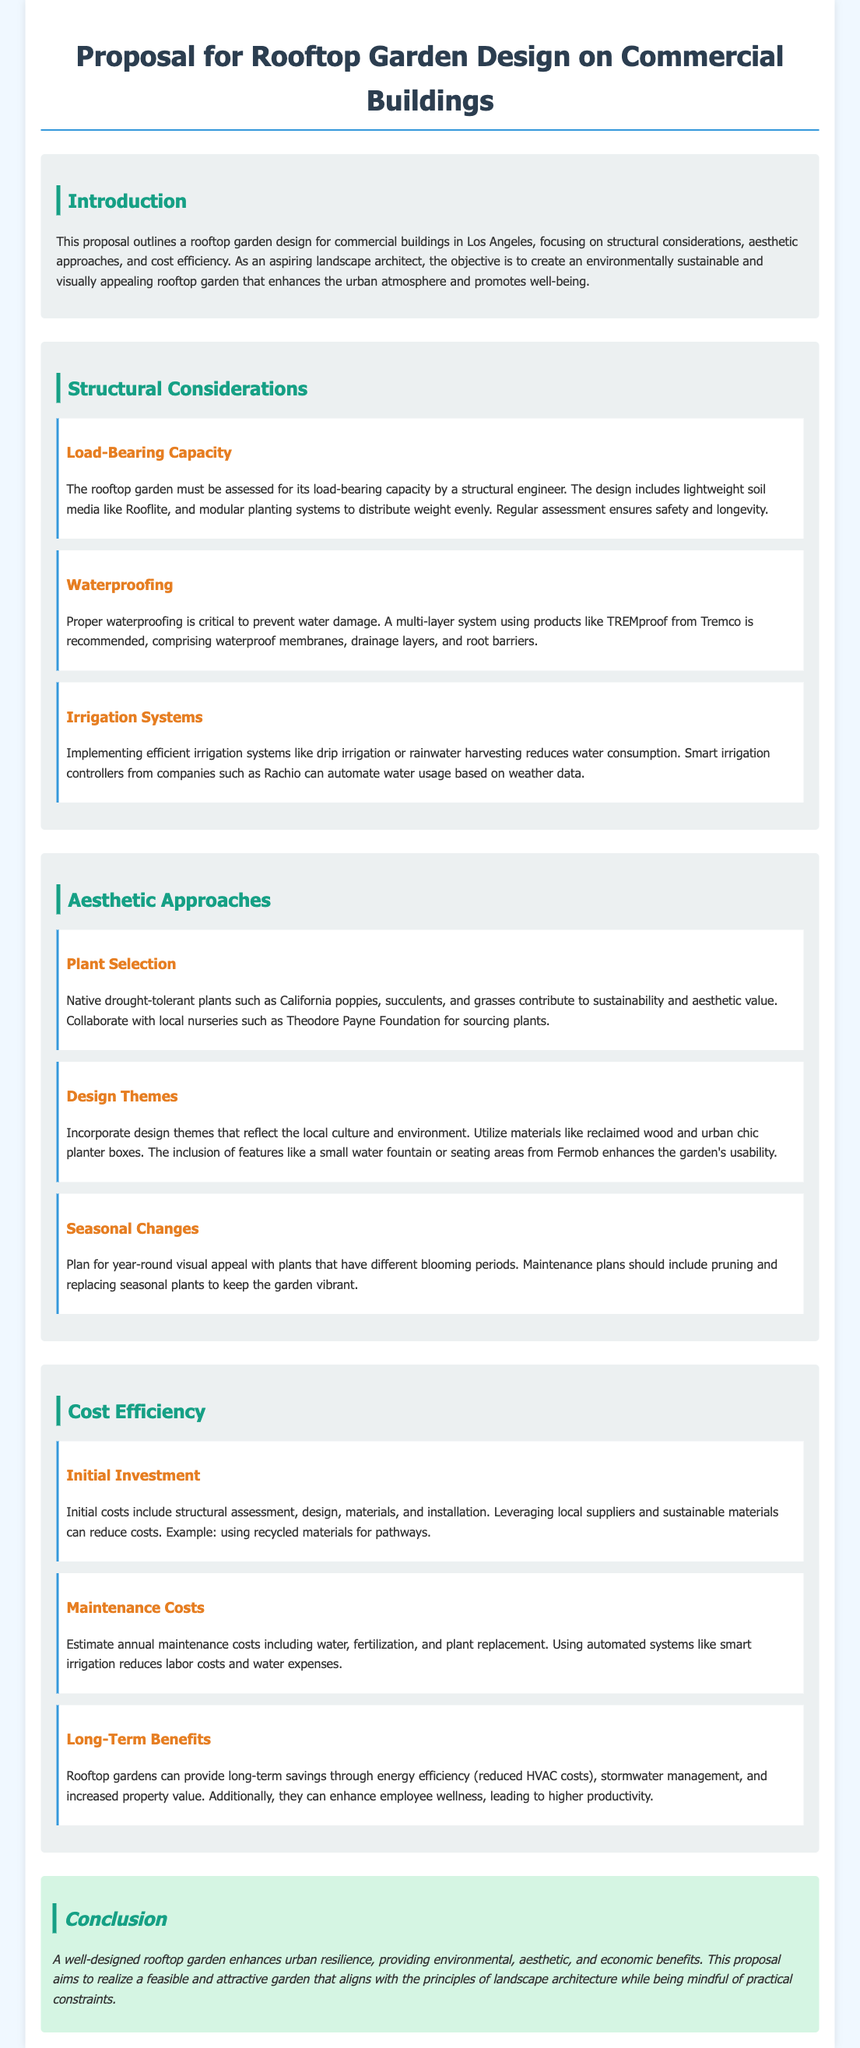what is the title of the proposal? The title is specifically mentioned at the beginning of the document as the focus of the proposal.
Answer: Proposal for Rooftop Garden Design on Commercial Buildings who should assess the load-bearing capacity of the rooftop garden? This information is stated in the structural considerations section, indicating a professional role responsible for the assessment.
Answer: Structural engineer what type of irrigation system is recommended for efficiency? The document suggests specific irrigation systems known for their efficiency in water usage within the irrigation systems subsection.
Answer: Drip irrigation what is the purpose of using lightweight soil media like Rooflite? The reason is specified in the load-bearing capacity subsection, highlighting its importance in weight distribution.
Answer: Distribute weight evenly which type of plants are recommended for the garden design? Native plants are specified in the aesthetic approaches section, reflecting the document's emphasis on sustainability.
Answer: Native drought-tolerant plants what is one long-term benefit of rooftop gardens mentioned? The document elaborates on multiple long-term savings associated with rooftop gardens, and one such benefit is highlighted distinctly.
Answer: Energy efficiency what is suggested to enhance the garden's usability? The aesthetic approaches section includes features designed to improve functionality, indicating which elements are important for usability.
Answer: Seating areas what should maintenance plans include for year-round appeal? The document outlines specific tasks needed for upkeep and seasonal visual interest, indicating what should be part of these plans.
Answer: Pruning and replacing seasonal plants how can initial costs be reduced according to the proposal? The proposal describes strategies to alleviate initial expenses, focusing specifically on suppliers and material choices.
Answer: Leveraging local suppliers and sustainable materials 